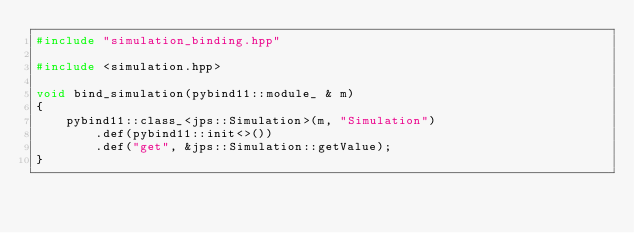<code> <loc_0><loc_0><loc_500><loc_500><_C++_>#include "simulation_binding.hpp"

#include <simulation.hpp>

void bind_simulation(pybind11::module_ & m)
{
    pybind11::class_<jps::Simulation>(m, "Simulation")
        .def(pybind11::init<>())
        .def("get", &jps::Simulation::getValue);
}
</code> 